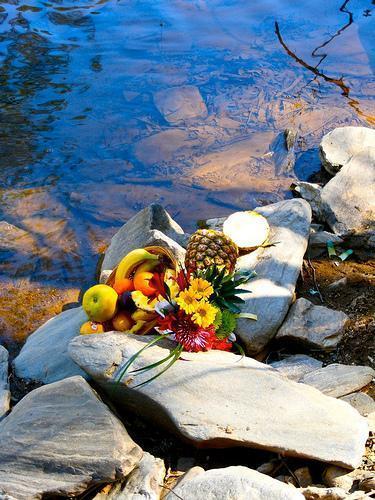How many people are in the photo?
Give a very brief answer. 0. How many yellow flowers are in the picture?
Give a very brief answer. 3. 